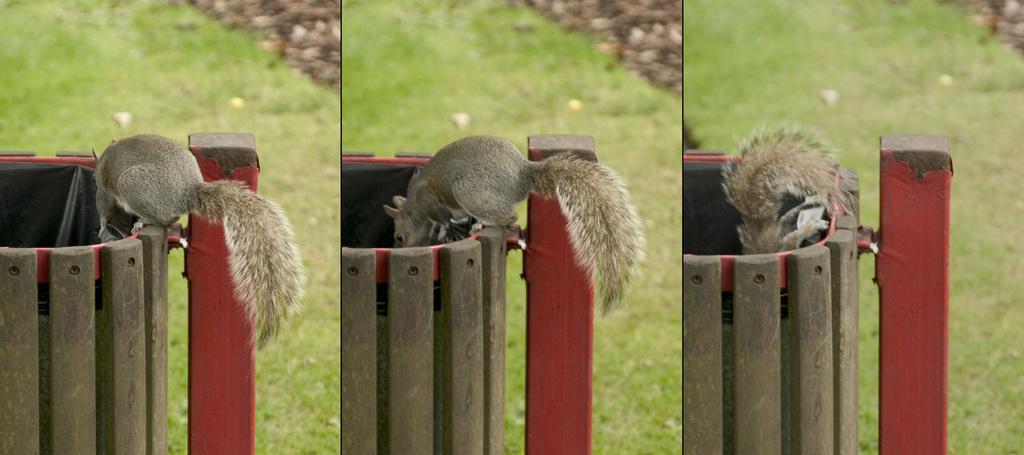Please provide a concise description of this image. In the image there is a squirrel standing on a wooden dustbin and staring inside, behind it, it's a grassland, this is a photo grid image. 